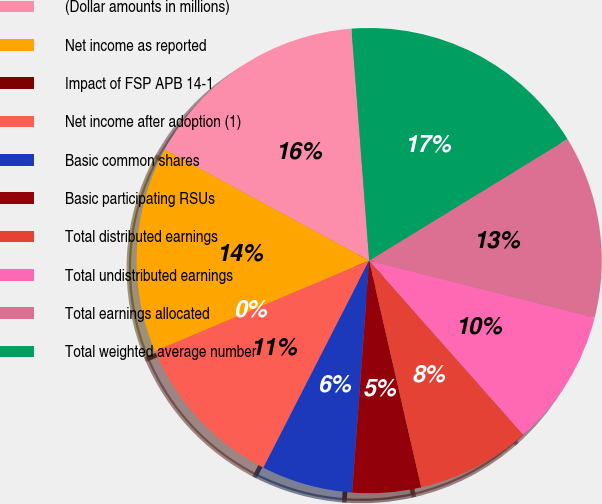Convert chart to OTSL. <chart><loc_0><loc_0><loc_500><loc_500><pie_chart><fcel>(Dollar amounts in millions)<fcel>Net income as reported<fcel>Impact of FSP APB 14-1<fcel>Net income after adoption (1)<fcel>Basic common shares<fcel>Basic participating RSUs<fcel>Total distributed earnings<fcel>Total undistributed earnings<fcel>Total earnings allocated<fcel>Total weighted average number<nl><fcel>15.87%<fcel>14.29%<fcel>0.0%<fcel>11.11%<fcel>6.35%<fcel>4.76%<fcel>7.94%<fcel>9.52%<fcel>12.7%<fcel>17.46%<nl></chart> 